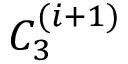<formula> <loc_0><loc_0><loc_500><loc_500>C _ { 3 } ^ { ( i + 1 ) }</formula> 